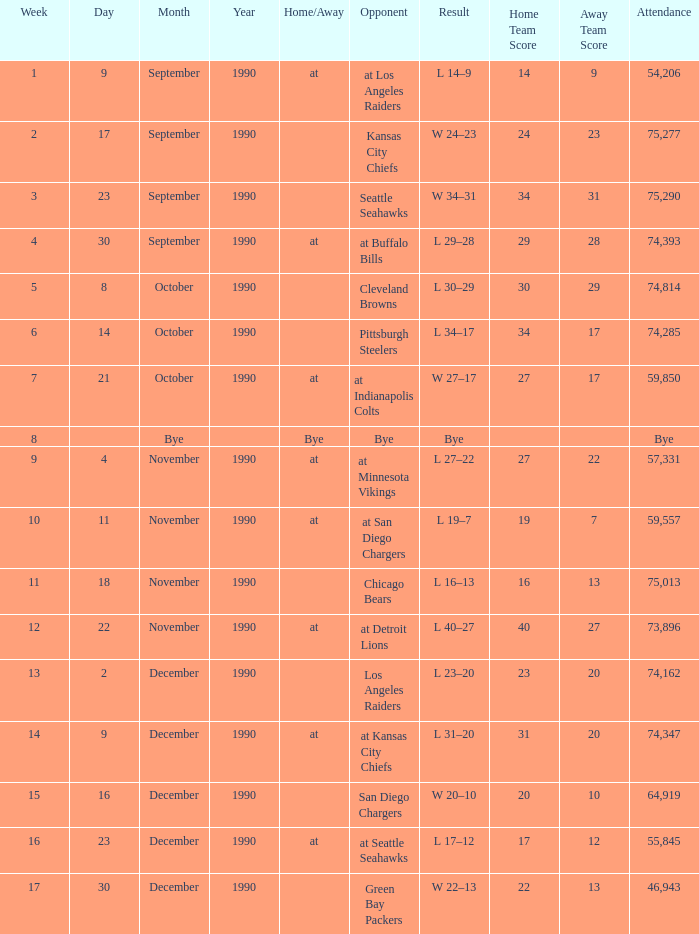Could you parse the entire table as a dict? {'header': ['Week', 'Day', 'Month', 'Year', 'Home/Away', 'Opponent', 'Result', 'Home Team Score', 'Away Team Score', 'Attendance'], 'rows': [['1', '9', 'September', '1990', 'at', 'at Los Angeles Raiders', 'L 14–9', '14', '9', '54,206'], ['2', '17', 'September', '1990', '', 'Kansas City Chiefs', 'W 24–23', '24', '23', '75,277'], ['3', '23', 'September', '1990', '', 'Seattle Seahawks', 'W 34–31', '34', '31', '75,290'], ['4', '30', 'September', '1990', 'at', 'at Buffalo Bills', 'L 29–28', '29', '28', '74,393'], ['5', '8', 'October', '1990', '', 'Cleveland Browns', 'L 30–29', '30', '29', '74,814'], ['6', '14', 'October', '1990', '', 'Pittsburgh Steelers', 'L 34–17', '34', '17', '74,285'], ['7', '21', 'October', '1990', 'at', 'at Indianapolis Colts', 'W 27–17', '27', '17', '59,850'], ['8', '', 'Bye', '', 'Bye', 'Bye', 'Bye', '', '', 'Bye'], ['9', '4', 'November', '1990', 'at', 'at Minnesota Vikings', 'L 27–22', '27', '22', '57,331'], ['10', '11', 'November', '1990', 'at', 'at San Diego Chargers', 'L 19–7', '19', '7', '59,557'], ['11', '18', 'November', '1990', '', 'Chicago Bears', 'L 16–13', '16', '13', '75,013'], ['12', '22', 'November', '1990', 'at', 'at Detroit Lions', 'L 40–27', '40', '27', '73,896'], ['13', '2', 'December', '1990', '', 'Los Angeles Raiders', 'L 23–20', '23', '20', '74,162'], ['14', '9', 'December', '1990', 'at', 'at Kansas City Chiefs', 'L 31–20', '31', '20', '74,347'], ['15', '16', 'December', '1990', '', 'San Diego Chargers', 'W 20–10', '20', '10', '64,919'], ['16', '23', 'December', '1990', 'at', 'at Seattle Seahawks', 'L 17–12', '17', '12', '55,845'], ['17', '30', 'December', '1990', '', 'Green Bay Packers', 'W 22–13', '22', '13', '46,943']]} How many weeks was there an attendance of 74,347? 14.0. 